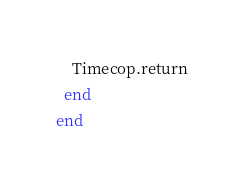Convert code to text. <code><loc_0><loc_0><loc_500><loc_500><_Ruby_>    Timecop.return
  end
end
</code> 